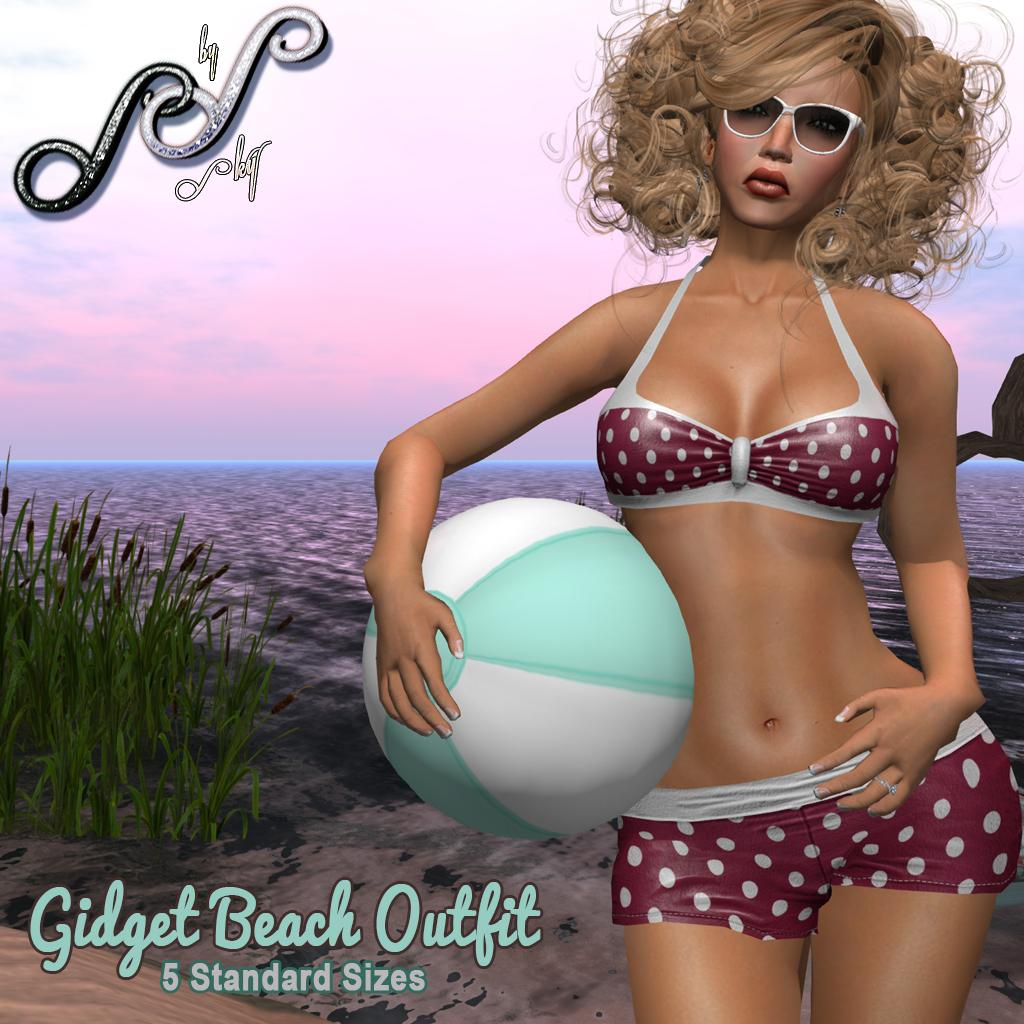What is the main subject of the cartoon picture in the image? There is a cartoon picture of a lady holding a ball in the image. What type of natural environment is depicted in the image? There is an ocean, sand, and plants visible in the image, which suggests a beach setting. What part of the sky is visible in the image? The sky is visible in the image. Is there any text present in the image? Yes, there is some text on the image. What type of jewel can be seen on the zebra's neck in the image? There is no zebra or jewel present in the image. How does the lady in the cartoon picture stop the ball from rolling away? The image does not show the lady using a brake or any other method to stop the ball from rolling away. 